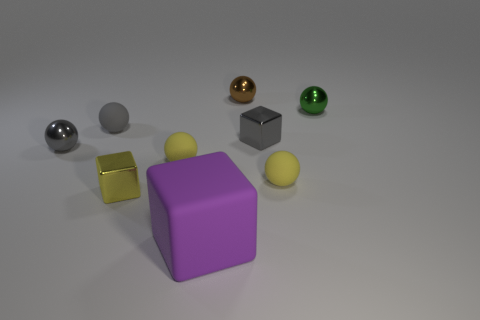Subtract 2 spheres. How many spheres are left? 4 Subtract all green balls. How many balls are left? 5 Subtract all tiny green spheres. How many spheres are left? 5 Subtract all red spheres. Subtract all green cylinders. How many spheres are left? 6 Subtract all balls. How many objects are left? 3 Subtract all small gray matte things. Subtract all tiny green cubes. How many objects are left? 8 Add 7 green balls. How many green balls are left? 8 Add 2 gray matte balls. How many gray matte balls exist? 3 Subtract 0 cyan cubes. How many objects are left? 9 